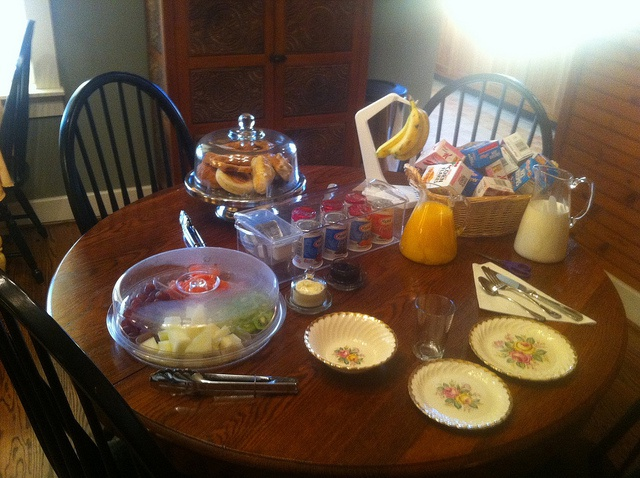Describe the objects in this image and their specific colors. I can see dining table in white, maroon, black, and gray tones, bowl in white, gray, tan, and olive tones, chair in white, black, and gray tones, chair in white, black, olive, and gray tones, and chair in white, lightgray, darkgray, gray, and lightblue tones in this image. 